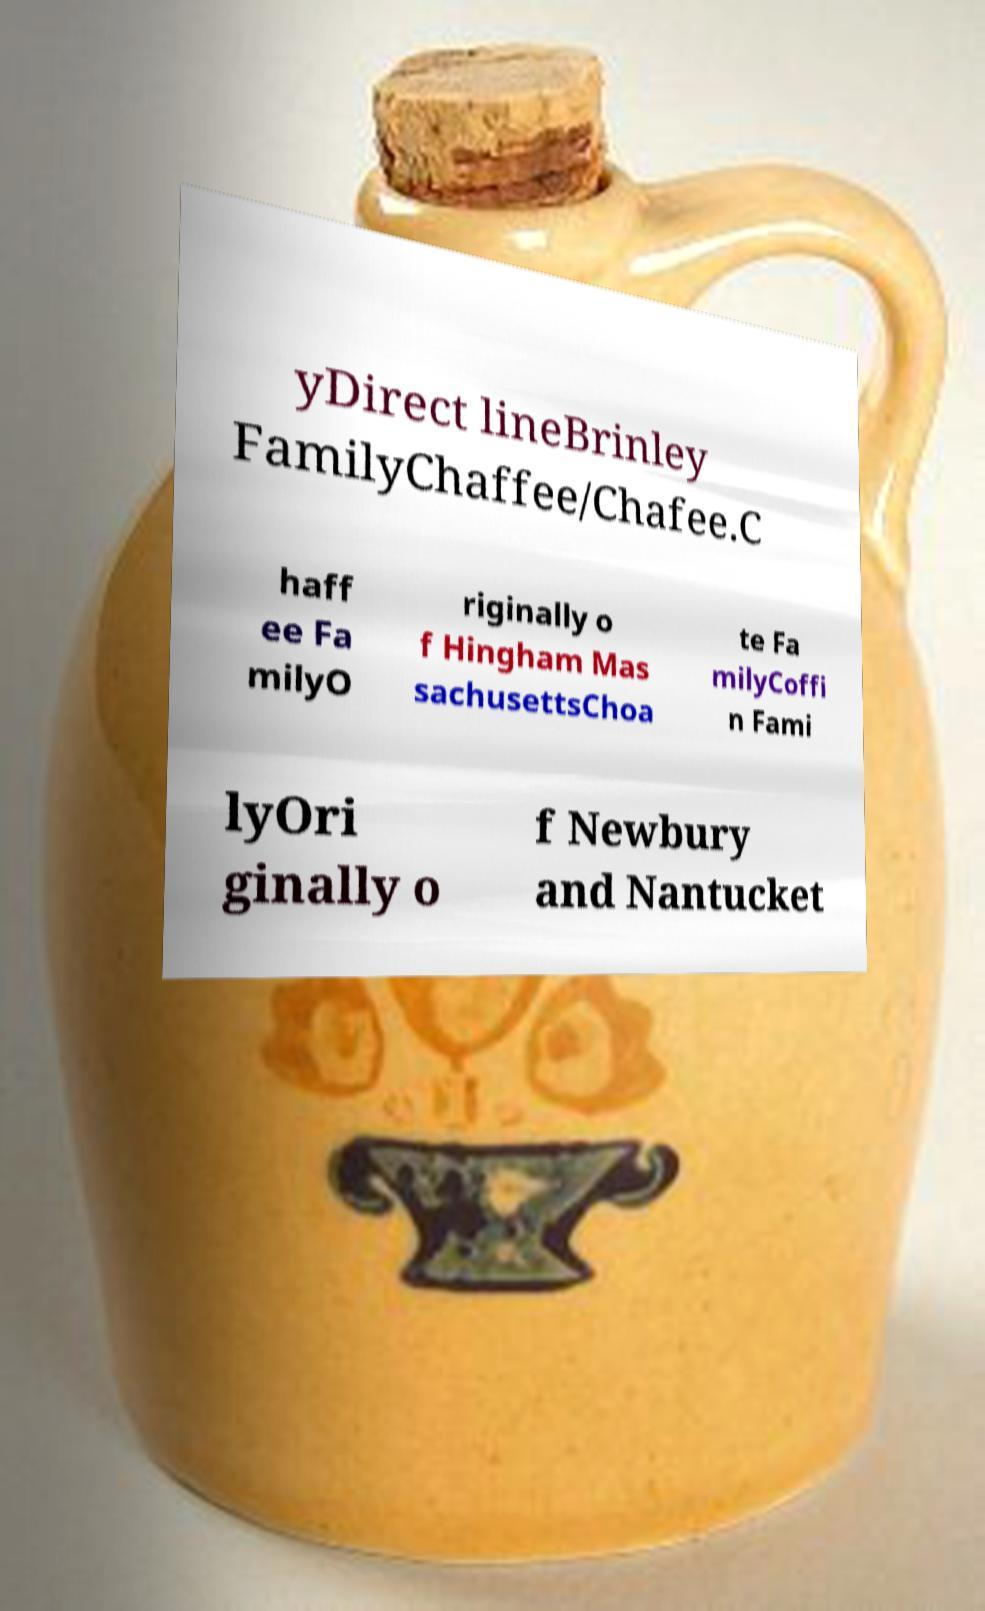Please identify and transcribe the text found in this image. yDirect lineBrinley FamilyChaffee/Chafee.C haff ee Fa milyO riginally o f Hingham Mas sachusettsChoa te Fa milyCoffi n Fami lyOri ginally o f Newbury and Nantucket 